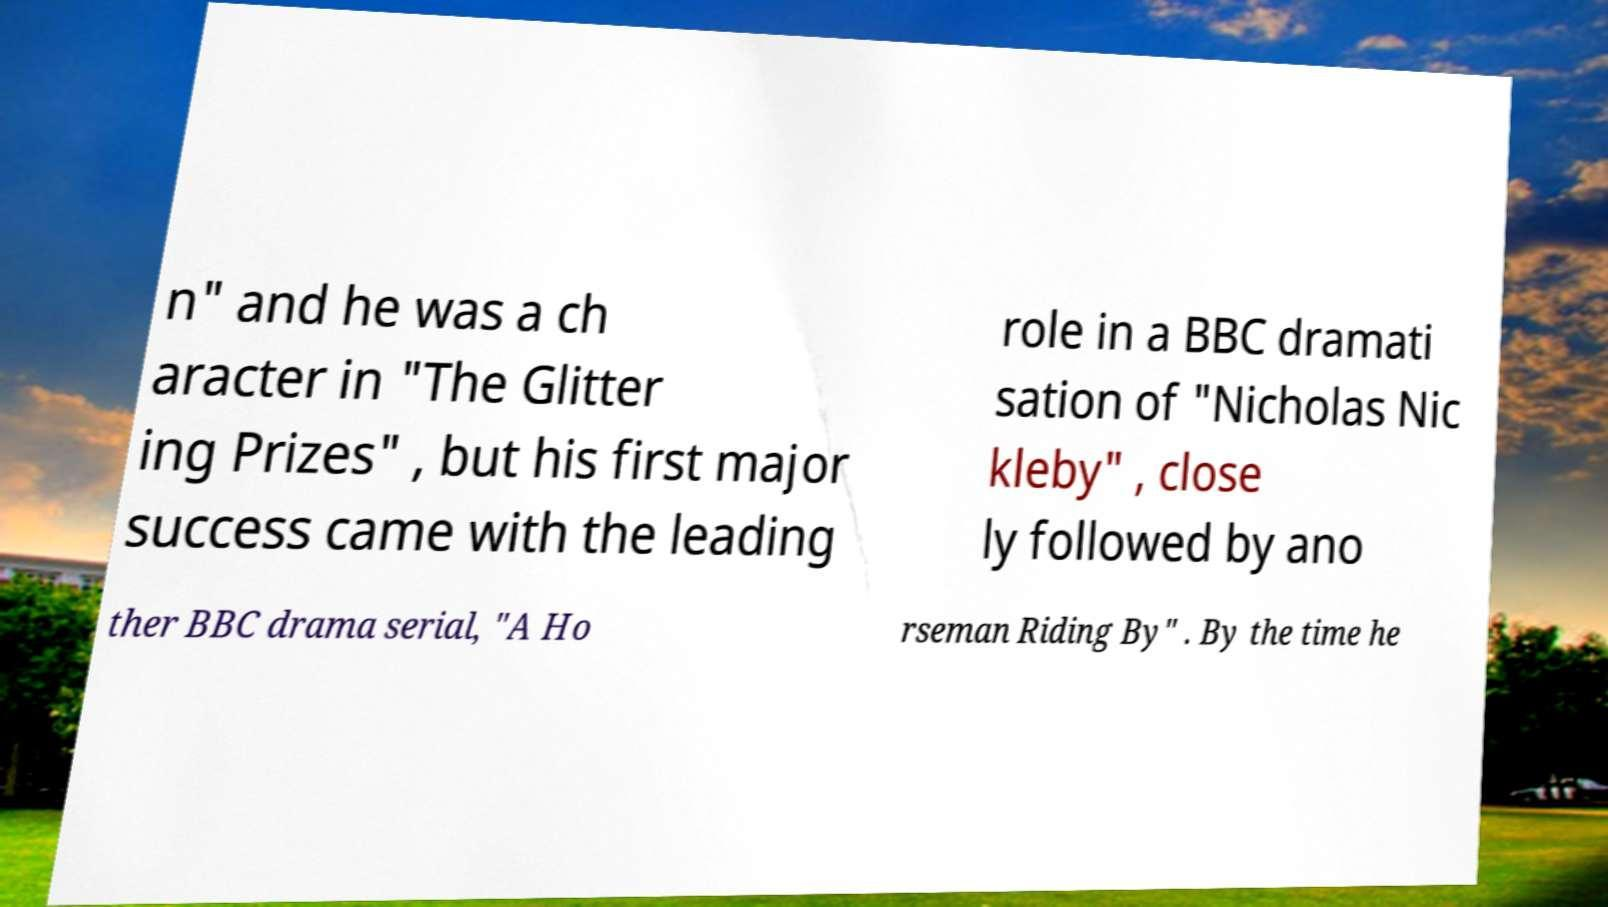Can you read and provide the text displayed in the image?This photo seems to have some interesting text. Can you extract and type it out for me? n" and he was a ch aracter in "The Glitter ing Prizes" , but his first major success came with the leading role in a BBC dramati sation of "Nicholas Nic kleby" , close ly followed by ano ther BBC drama serial, "A Ho rseman Riding By" . By the time he 